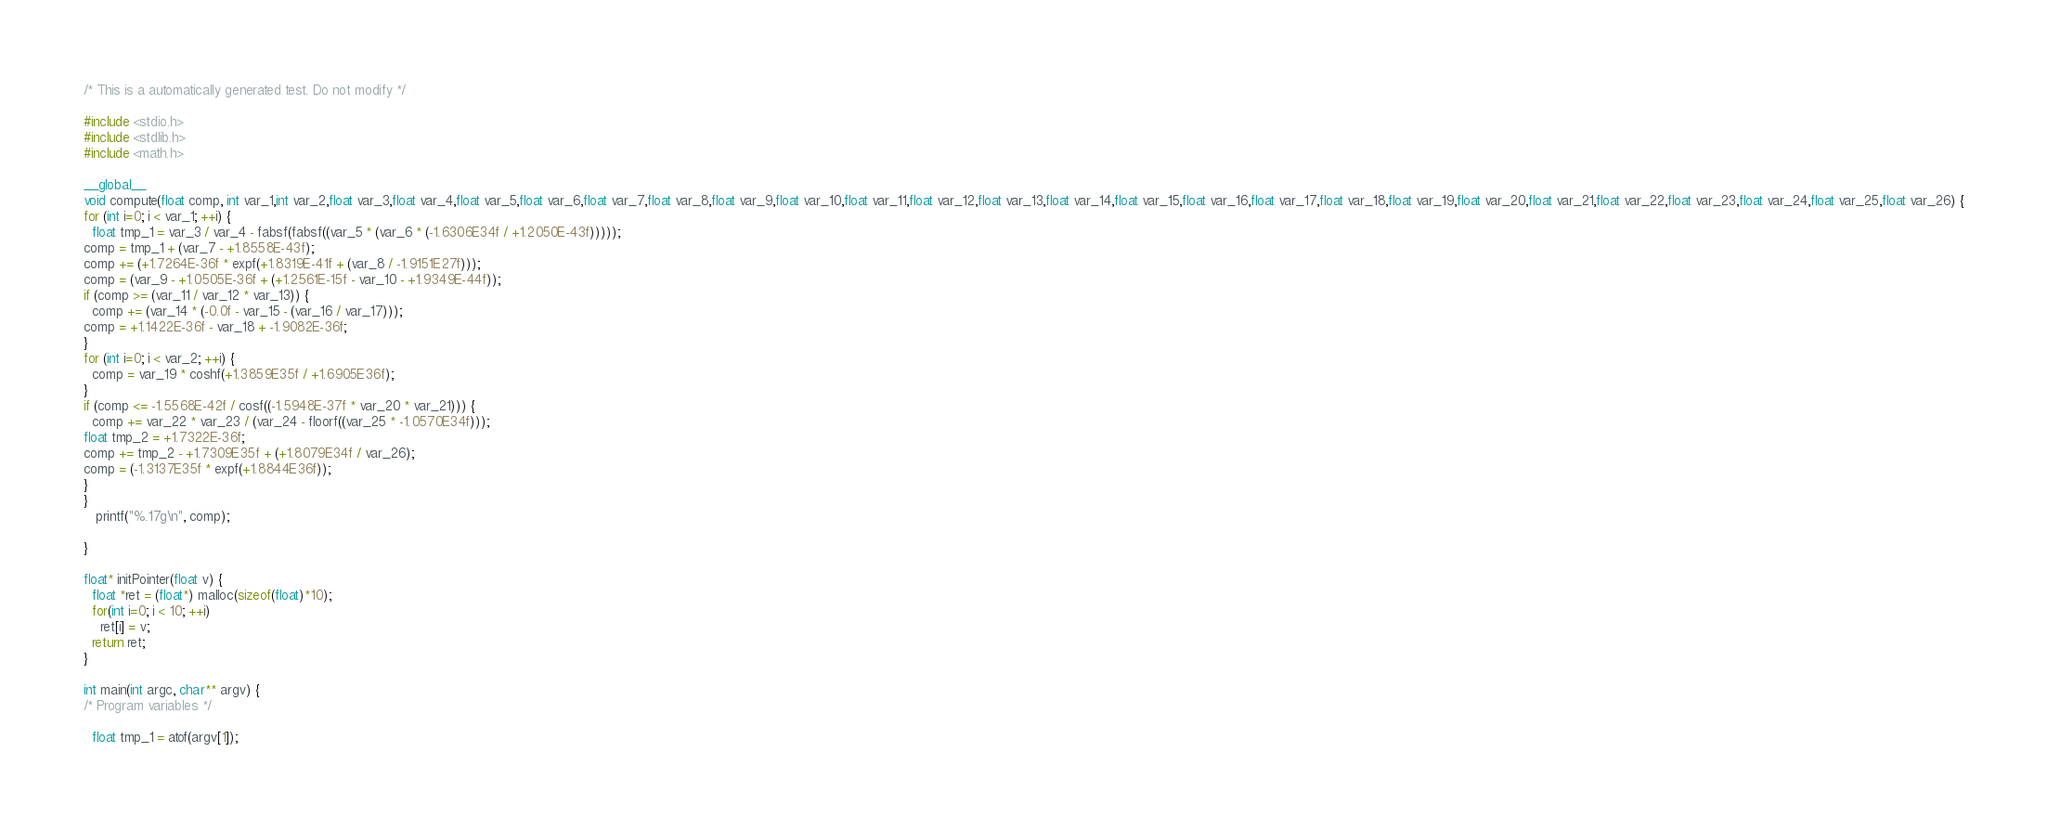<code> <loc_0><loc_0><loc_500><loc_500><_Cuda_>
/* This is a automatically generated test. Do not modify */

#include <stdio.h>
#include <stdlib.h>
#include <math.h>

__global__
void compute(float comp, int var_1,int var_2,float var_3,float var_4,float var_5,float var_6,float var_7,float var_8,float var_9,float var_10,float var_11,float var_12,float var_13,float var_14,float var_15,float var_16,float var_17,float var_18,float var_19,float var_20,float var_21,float var_22,float var_23,float var_24,float var_25,float var_26) {
for (int i=0; i < var_1; ++i) {
  float tmp_1 = var_3 / var_4 - fabsf(fabsf((var_5 * (var_6 * (-1.6306E34f / +1.2050E-43f)))));
comp = tmp_1 + (var_7 - +1.8558E-43f);
comp += (+1.7264E-36f * expf(+1.8319E-41f + (var_8 / -1.9151E27f)));
comp = (var_9 - +1.0505E-36f + (+1.2561E-15f - var_10 - +1.9349E-44f));
if (comp >= (var_11 / var_12 * var_13)) {
  comp += (var_14 * (-0.0f - var_15 - (var_16 / var_17)));
comp = +1.1422E-36f - var_18 + -1.9082E-36f;
}
for (int i=0; i < var_2; ++i) {
  comp = var_19 * coshf(+1.3859E35f / +1.6905E36f);
}
if (comp <= -1.5568E-42f / cosf((-1.5948E-37f * var_20 * var_21))) {
  comp += var_22 * var_23 / (var_24 - floorf((var_25 * -1.0570E34f)));
float tmp_2 = +1.7322E-36f;
comp += tmp_2 - +1.7309E35f + (+1.8079E34f / var_26);
comp = (-1.3137E35f * expf(+1.8844E36f));
}
}
   printf("%.17g\n", comp);

}

float* initPointer(float v) {
  float *ret = (float*) malloc(sizeof(float)*10);
  for(int i=0; i < 10; ++i)
    ret[i] = v;
  return ret;
}

int main(int argc, char** argv) {
/* Program variables */

  float tmp_1 = atof(argv[1]);</code> 